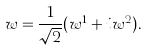<formula> <loc_0><loc_0><loc_500><loc_500>w = \frac { 1 } { \sqrt { 2 } } ( w ^ { 1 } + i w ^ { 2 } ) .</formula> 